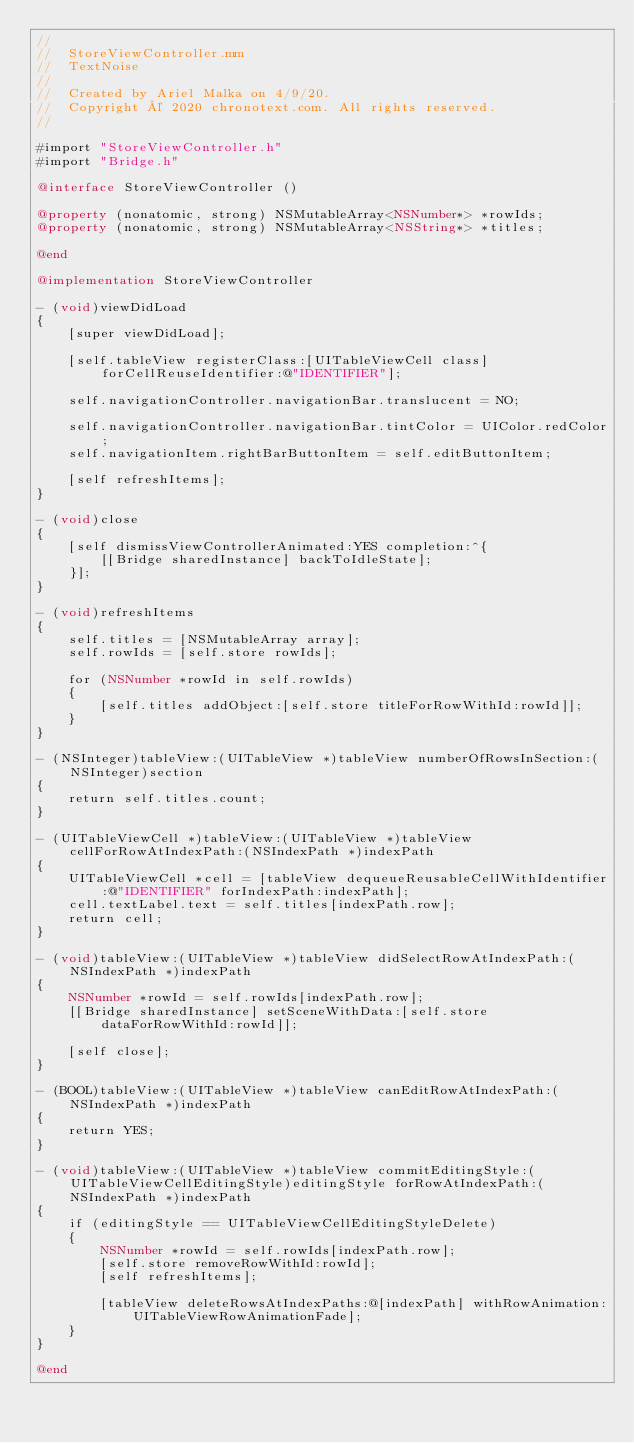Convert code to text. <code><loc_0><loc_0><loc_500><loc_500><_ObjectiveC_>//
//  StoreViewController.mm
//  TextNoise
//
//  Created by Ariel Malka on 4/9/20.
//  Copyright © 2020 chronotext.com. All rights reserved.
//

#import "StoreViewController.h"
#import "Bridge.h"

@interface StoreViewController ()

@property (nonatomic, strong) NSMutableArray<NSNumber*> *rowIds;
@property (nonatomic, strong) NSMutableArray<NSString*> *titles;

@end

@implementation StoreViewController

- (void)viewDidLoad
{
    [super viewDidLoad];

    [self.tableView registerClass:[UITableViewCell class] forCellReuseIdentifier:@"IDENTIFIER"];
    
    self.navigationController.navigationBar.translucent = NO;
    
    self.navigationController.navigationBar.tintColor = UIColor.redColor;
    self.navigationItem.rightBarButtonItem = self.editButtonItem;
    
    [self refreshItems];
}

- (void)close
{
    [self dismissViewControllerAnimated:YES completion:^{
        [[Bridge sharedInstance] backToIdleState];
    }];
}

- (void)refreshItems
{
    self.titles = [NSMutableArray array];
    self.rowIds = [self.store rowIds];

    for (NSNumber *rowId in self.rowIds)
    {
        [self.titles addObject:[self.store titleForRowWithId:rowId]];
    }
}

- (NSInteger)tableView:(UITableView *)tableView numberOfRowsInSection:(NSInteger)section
{
    return self.titles.count;
}

- (UITableViewCell *)tableView:(UITableView *)tableView cellForRowAtIndexPath:(NSIndexPath *)indexPath
{
    UITableViewCell *cell = [tableView dequeueReusableCellWithIdentifier:@"IDENTIFIER" forIndexPath:indexPath];
    cell.textLabel.text = self.titles[indexPath.row];
    return cell;
}

- (void)tableView:(UITableView *)tableView didSelectRowAtIndexPath:(NSIndexPath *)indexPath
{
    NSNumber *rowId = self.rowIds[indexPath.row];
    [[Bridge sharedInstance] setSceneWithData:[self.store dataForRowWithId:rowId]];
    
    [self close];
}

- (BOOL)tableView:(UITableView *)tableView canEditRowAtIndexPath:(NSIndexPath *)indexPath
{
    return YES;
}

- (void)tableView:(UITableView *)tableView commitEditingStyle:(UITableViewCellEditingStyle)editingStyle forRowAtIndexPath:(NSIndexPath *)indexPath
{
    if (editingStyle == UITableViewCellEditingStyleDelete)
    {
        NSNumber *rowId = self.rowIds[indexPath.row];
        [self.store removeRowWithId:rowId];
        [self refreshItems];
        
        [tableView deleteRowsAtIndexPaths:@[indexPath] withRowAnimation:UITableViewRowAnimationFade];
    }
}

@end
</code> 